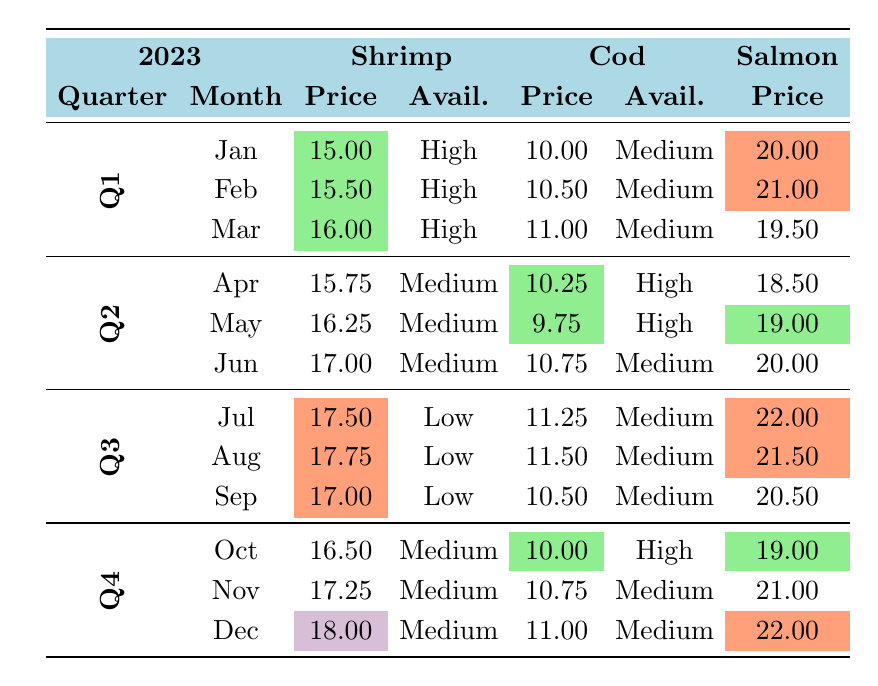What was the average price per pound for shrimp in Q1 2023? To find the average price for shrimp in Q1, we need to sum the prices for January, February, and March. The prices are 15.00, 15.50, and 16.00. Adding them gives 15.00 + 15.50 + 16.00 = 46.50. Now, divide this sum by the number of months, which is 3: 46.50 / 3 = 15.50.
Answer: 15.50 Which month had the highest average price for cod in 2023? Looking through the prices of cod for each month, they are as follows: January (10.00), February (10.50), March (11.00), April (10.25), May (9.75), June (10.75), July (11.25), August (11.50), September (10.50), October (10.00), November (10.75), December (11.00). The highest price is in August at 11.50.
Answer: August Was the availability of salmon high in any month in Q2? By examining the availability of salmon for April, May, and June, we see: April (Medium), May (High), June (Medium). Since May is classified as High availability, the answer is yes.
Answer: Yes What is the total average price for shrimp across all quarters in 2023? First, sum the average prices for shrimp by quarter: Q1 (15.50 from the previous question), Q2 (average of 15.75, 16.25, 17.00 is (15.75 + 16.25 + 17.00)/3 = 16.00), Q3 (average of 17.50, 17.75, 17.00 is (17.50 + 17.75 + 17.00)/3 = 17.08) and Q4 (average of 16.50, 17.25, 18.00 is (16.50 + 17.25 + 18.00)/3 = 17.25). Now add these averages: 15.50 + 16.00 + 17.08 + 17.25 = 65.83 and divide by 4 (the number of quarters): 65.83 / 4 = 16.46.
Answer: 16.46 In which quarter did the price of shrimp first increase in 2023? Inspecting the quarterly prices for shrimp, we see that the price started at 15.00 in January, then increased to 15.50 in February, and continued to go up until reaching 16.00 in March. The price increase occurs in Q1, as it rises from January through March.
Answer: Q1 